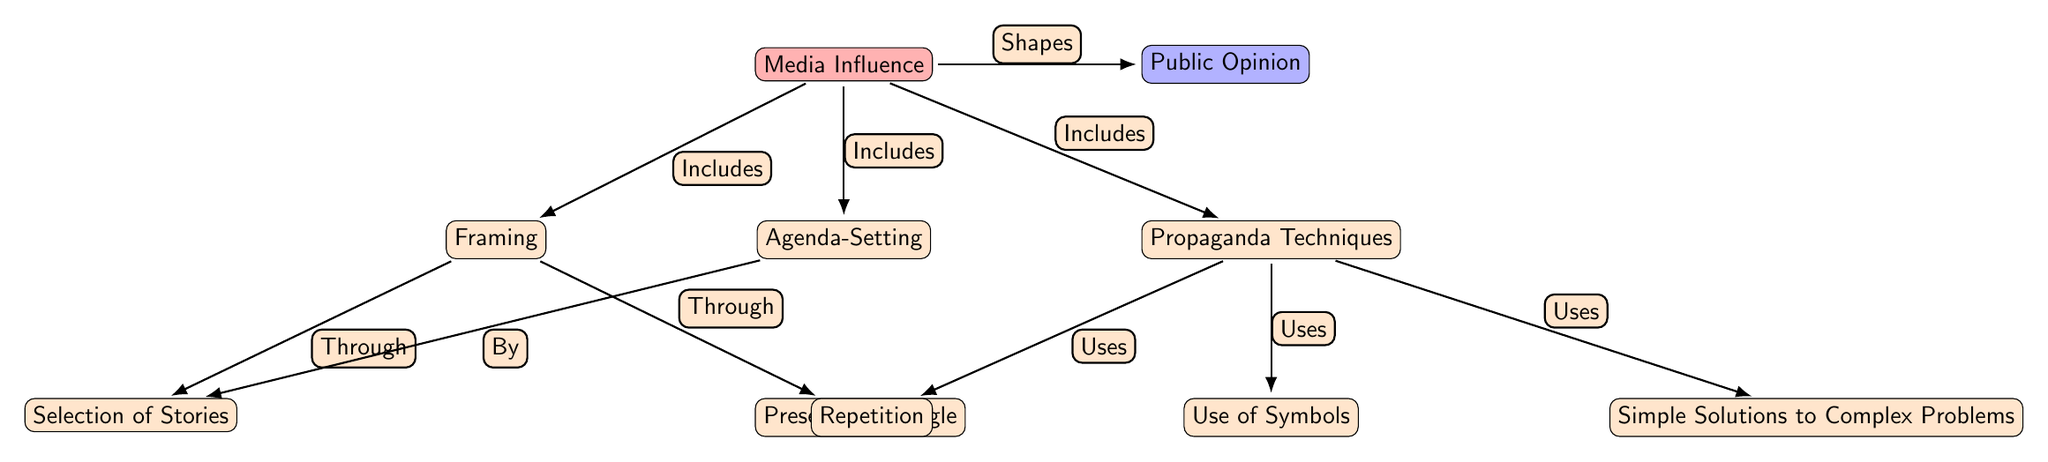What is the main subject of the diagram? The main subject of the diagram is shown at the top node labeled "Media Influence," which is connected to the other elements.
Answer: Media Influence How many main nodes are there in the diagram? The diagram contains five main nodes: "Media Influence," "Public Opinion," "Framing," "Agenda-Setting," and "Propaganda Techniques."
Answer: Five What is one component of Framing? The diagram shows "Selection of Stories" as one of the sub-nodes connected to "Framing."
Answer: Selection of Stories Which node is connected to "Agenda-Setting" by the label "By"? The node that connects to "Agenda-Setting" with the label "By" is "Selection of Stories."
Answer: Selection of Stories What type of techniques are included in the "Propaganda Techniques" node? The "Propaganda Techniques" node includes "Repetition," "Use of Symbols," and "Simple Solutions to Complex Problems," as shown by the sub-nodes connected with the label "Uses."
Answer: Repetition, Use of Symbols, Simple Solutions to Complex Problems How does media influence public opinion according to the diagram? The diagram illustrates this influence through connections indicating that "Media Influence" leads to changes in "Public Opinion," and that influence happens through "Framing," "Agenda-Setting," and "Propaganda Techniques."
Answer: Through Framing, Agenda-Setting, Propaganda Techniques What two nodes share the label "Includes" in relation to Media Influence? Both "Framing" and "Agenda-Setting" share the label "Includes" in relation to the "Media Influence" node, indicating that they are included as components of how media influences public opinion.
Answer: Framing, Agenda-Setting What does the "Presentation Angle" sub-node fall under? The "Presentation Angle" is a sub-node connected to the "Framing" node, indicating it is one aspect of how framing can shape media influence.
Answer: Framing Which node is directly affected by "Selection of Stories"? The node "Framing" is directly affected by "Selection of Stories," as shown in the diagram with a connection labeled "Through."
Answer: Framing 